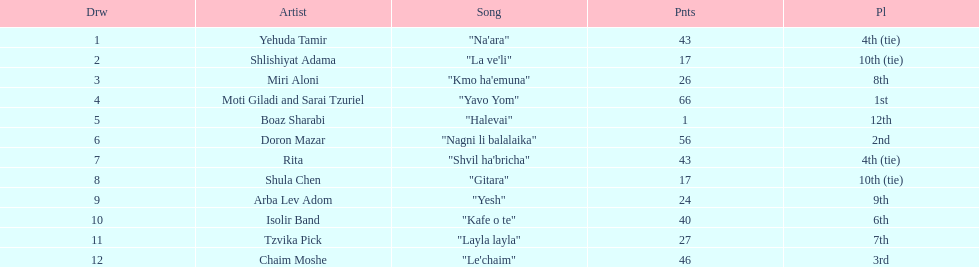What song earned the most points? "Yavo Yom". 